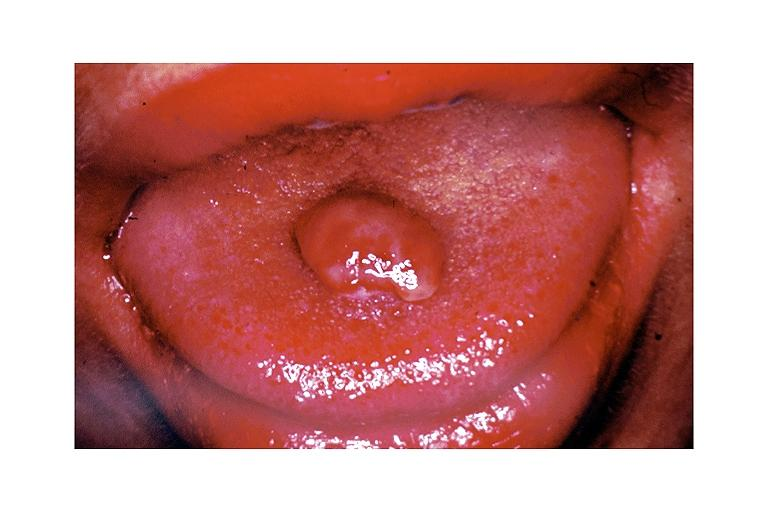where is this?
Answer the question using a single word or phrase. Oral 